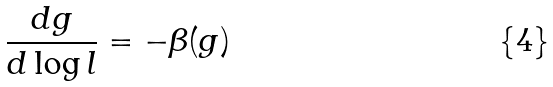<formula> <loc_0><loc_0><loc_500><loc_500>\frac { d g } { d \log l } = - \beta ( g )</formula> 